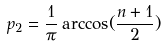Convert formula to latex. <formula><loc_0><loc_0><loc_500><loc_500>p _ { 2 } = \frac { 1 } { \pi } \arccos ( \frac { n + 1 } { 2 } )</formula> 